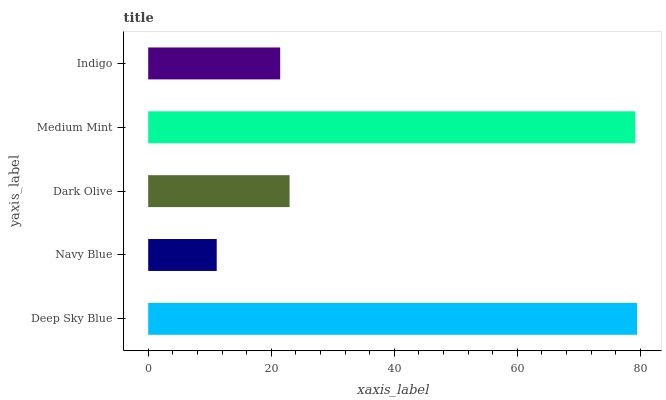Is Navy Blue the minimum?
Answer yes or no. Yes. Is Deep Sky Blue the maximum?
Answer yes or no. Yes. Is Dark Olive the minimum?
Answer yes or no. No. Is Dark Olive the maximum?
Answer yes or no. No. Is Dark Olive greater than Navy Blue?
Answer yes or no. Yes. Is Navy Blue less than Dark Olive?
Answer yes or no. Yes. Is Navy Blue greater than Dark Olive?
Answer yes or no. No. Is Dark Olive less than Navy Blue?
Answer yes or no. No. Is Dark Olive the high median?
Answer yes or no. Yes. Is Dark Olive the low median?
Answer yes or no. Yes. Is Indigo the high median?
Answer yes or no. No. Is Indigo the low median?
Answer yes or no. No. 